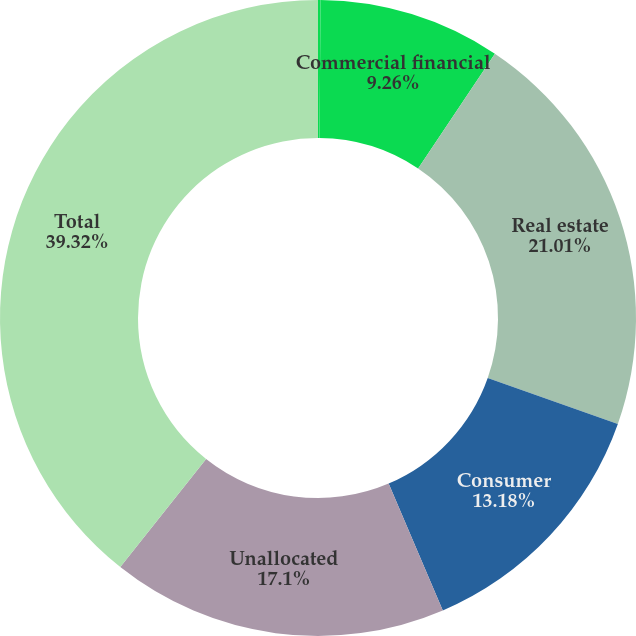<chart> <loc_0><loc_0><loc_500><loc_500><pie_chart><fcel>December 31<fcel>Commercial financial<fcel>Real estate<fcel>Consumer<fcel>Unallocated<fcel>Total<nl><fcel>0.13%<fcel>9.26%<fcel>21.02%<fcel>13.18%<fcel>17.1%<fcel>39.33%<nl></chart> 